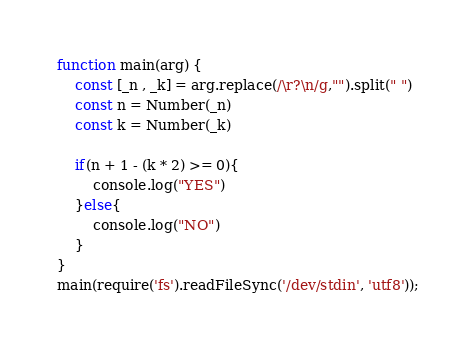<code> <loc_0><loc_0><loc_500><loc_500><_TypeScript_>function main(arg) {
    const [_n , _k] = arg.replace(/\r?\n/g,"").split(" ")
    const n = Number(_n)
    const k = Number(_k)

    if(n + 1 - (k * 2) >= 0){
        console.log("YES")
    }else{
        console.log("NO")
    }
}
main(require('fs').readFileSync('/dev/stdin', 'utf8'));
</code> 